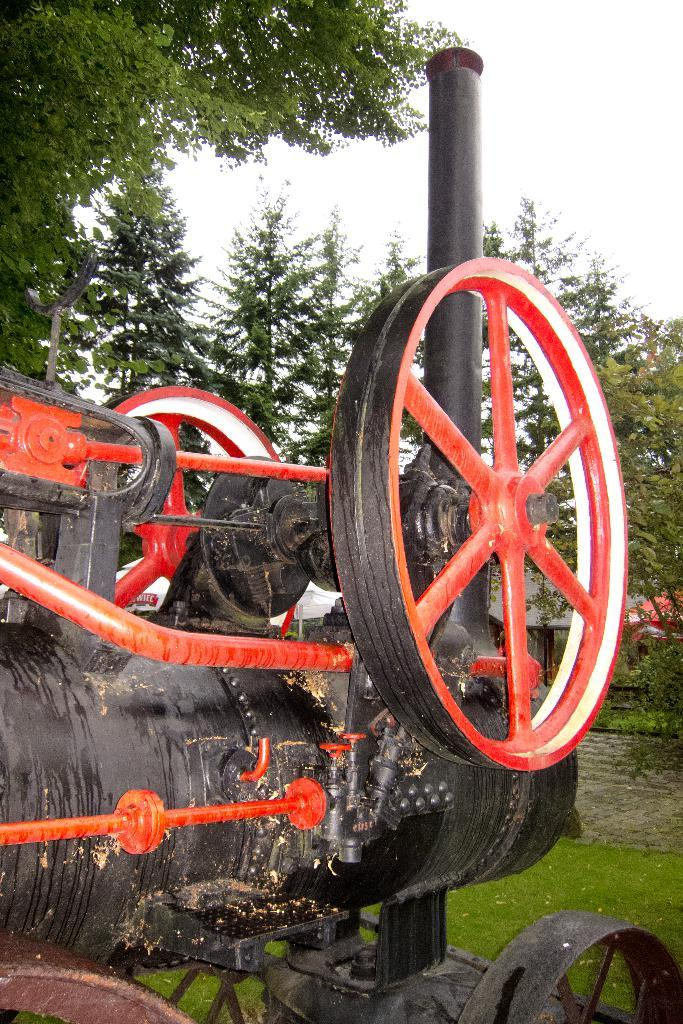What is the main subject in the center of the image? There is a vehicle in the center of the image. What can be seen in the background of the image? There are trees and a shed in the background of the image. What is visible at the bottom of the image? The ground is visible at the bottom of the image. What type of mist can be seen surrounding the vehicle in the image? There is no mist present in the image; the vehicle is surrounded by trees and a shed. 